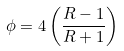Convert formula to latex. <formula><loc_0><loc_0><loc_500><loc_500>\phi = 4 \left ( \frac { R - 1 } { R + 1 } \right )</formula> 